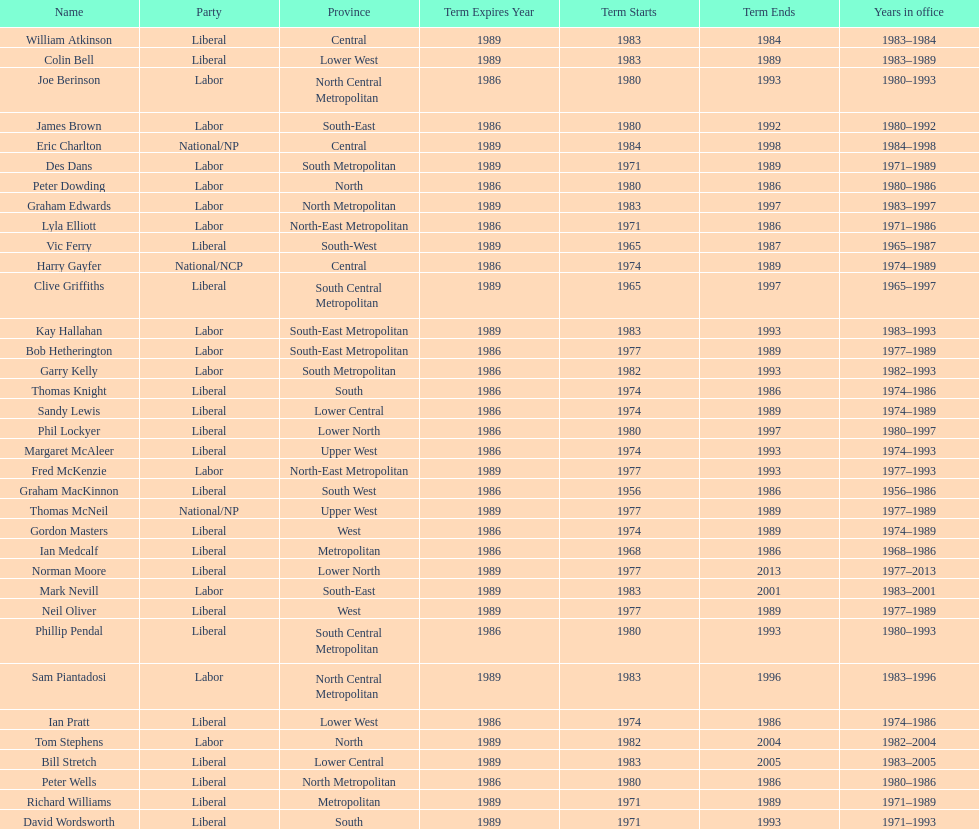Hame the last member listed whose last name begins with "p". Ian Pratt. 